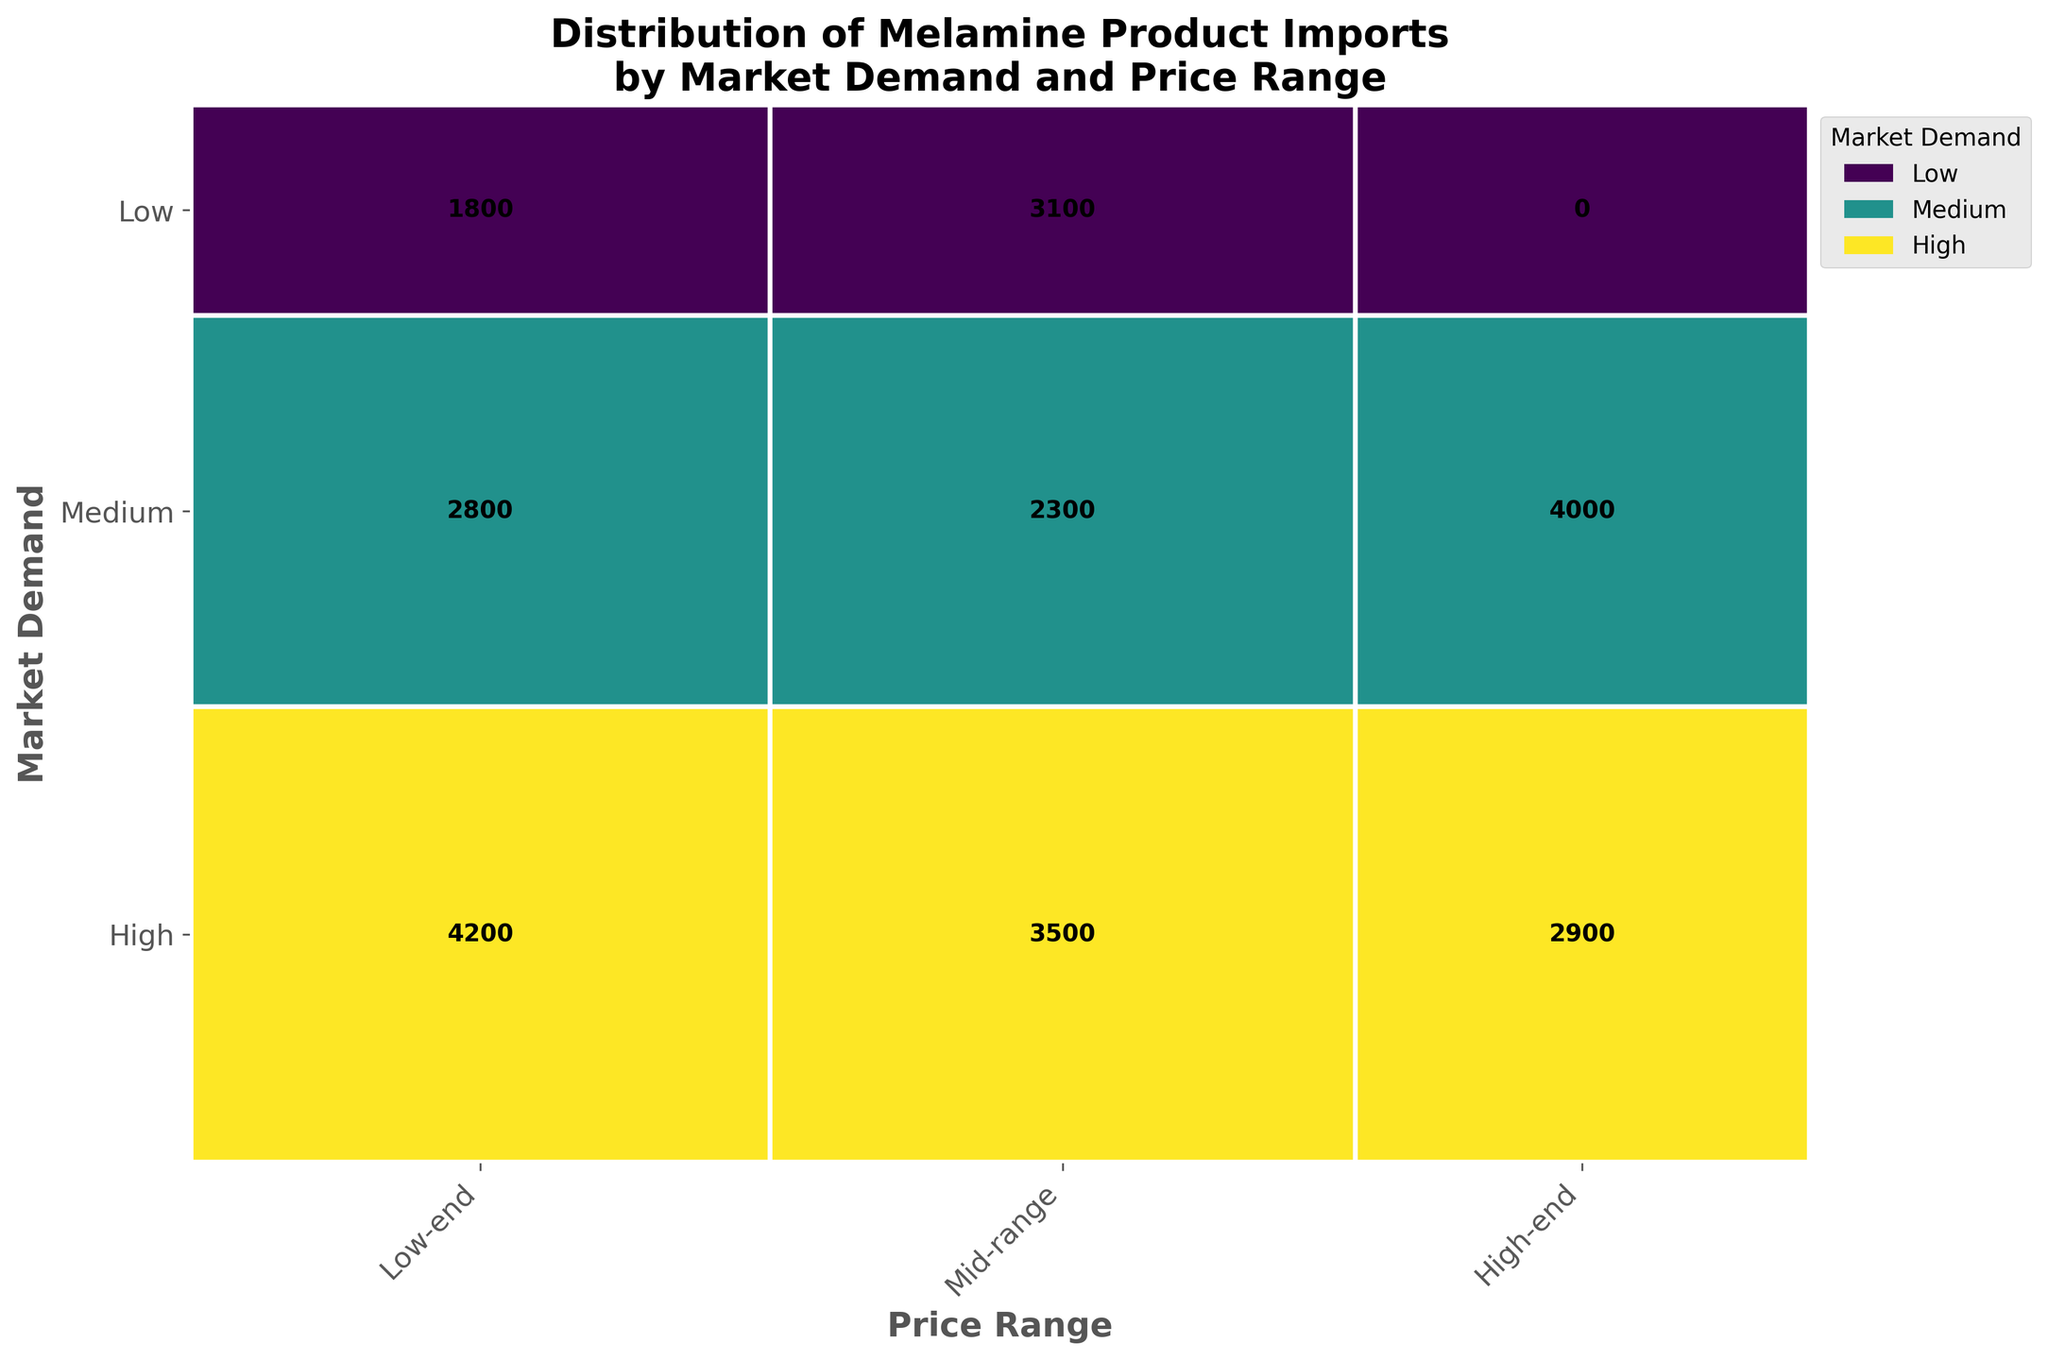What's the title of the figure? The title is often found at the top of the figure, describing the content of the plot. Here, it states the main subject of visualization.
Answer: Distribution of Melamine Product Imports by Market Demand and Price Range How many unique Product Types are represented in the figure? Each rectangle within the mosaic plot corresponds to a unique combination of Market Demand and Price Range for a specific product type. By counting these unique rectangles, we can identify the number of product types.
Answer: 10 Which Price Range has the highest total import volume? By looking at the rectangles' cumulative widths along the x-axis, we can assess which Price Range has the largest area. The collective width of the Mid-range rectangles seems greater.
Answer: Mid-range Which Market Demand category has the highest total import volume? By examining the cumulative height of rectangles along the y-axis, we can determine which Market Demand category has the greatest area. The High demand rectangles dominate more.
Answer: High What is the import volume for Food Storage Containers? According to the plot's text labels, each rectangle is marked with the specific import volume for its category. Locate the rectangle for Food Storage Containers.
Answer: 4200 What is the total import volume for Kitchenware Sets and Tableware Accessories combined? Find the import volumes for both categories from their respective rectangles and sum them up. Kitchenware Sets is 2900 and Tableware Accessories is 2100.
Answer: 5000 Which product type has the lowest import volume? Locate and compare the text labels within each rectangle to identify the smallest value. Kitchen Utensils have the smallest import volume.
Answer: Kitchen Utensils How does the import volume of Bakeware compare to that of Picnicware? Refer to the text labels within the rectangles for Bakeware and Picnicware. Bakeware is substantially higher. Bakeware is 2300 whereas Picnicware is 1800.
Answer: Bakeware is higher Which combination of Market Demand and Price Range has the highest import volume? Locate the rectangle with the largest value in terms of the text labels, which marks the highest import volume combination.
Answer: High demand and Low-end price range Is the import volume evenly distributed among different Price Ranges within the High Market Demand category? Check the heights of rectangles within the High Market Demand row. Notice if one or more Price Ranges have significantly higher or lower values. The Low-end has more volume, but the others are almost balanced.
Answer: No 